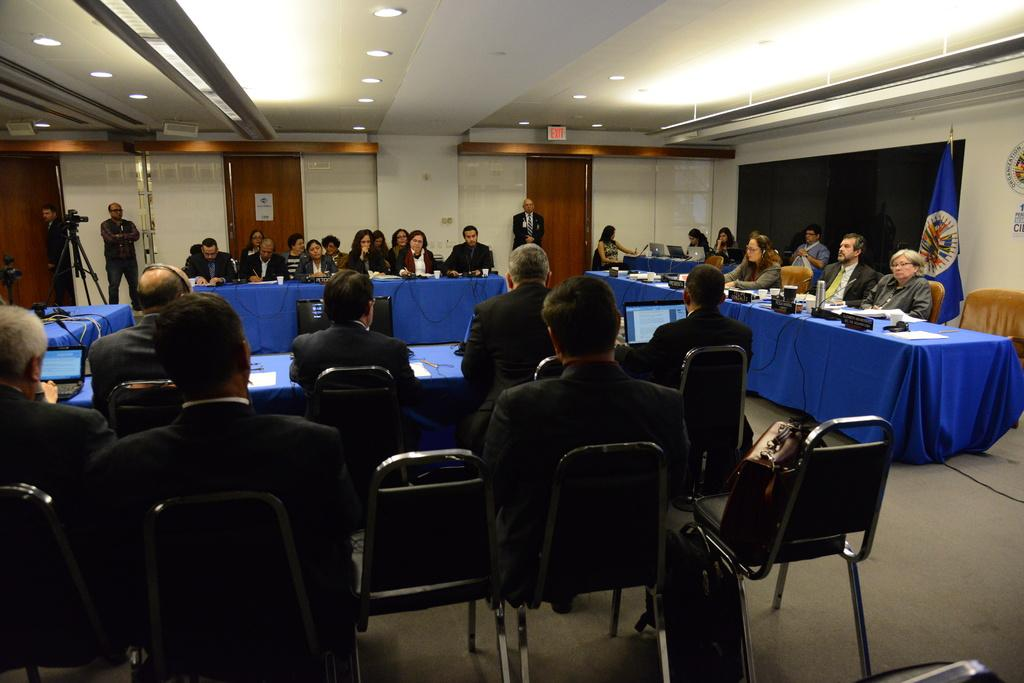What type of room is shown in the image? The image depicts a conference room. What are the people in the room doing? People are seated in the room, which suggests they are attending a meeting or presentation. What can be seen near the door of the room? Two people are standing at the door. What is the purpose of the flag in the room? The flag's purpose is not specified in the image, but it may represent a company, organization, or country. What is being used to capture the scene in the room? A camera is recording the scene. What is providing light in the room? There are lights on the ceiling. What type of skirt is the camera wearing in the image? The camera is an inanimate object and does not wear clothing, such as a skirt, in the image. 